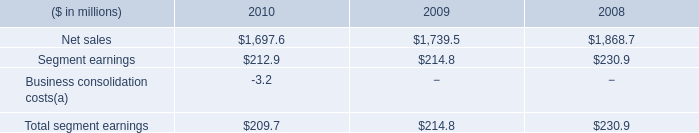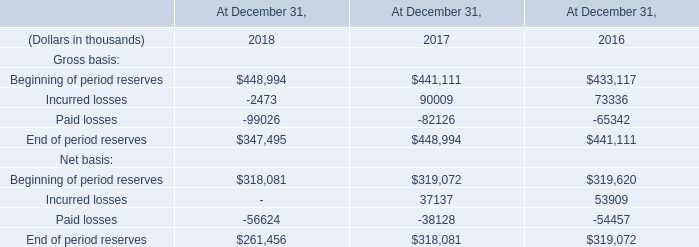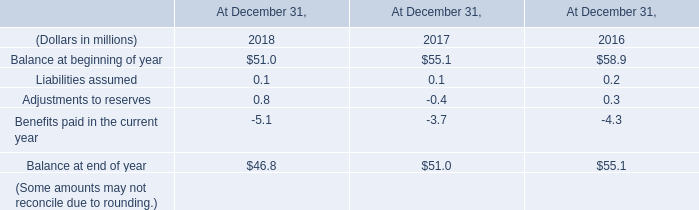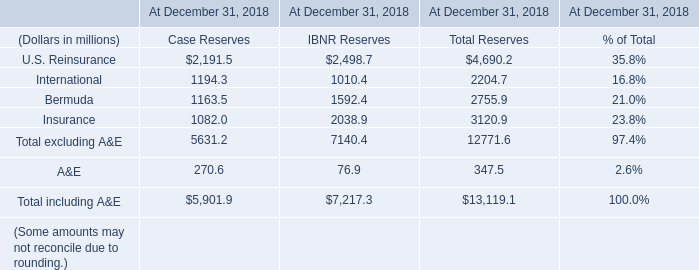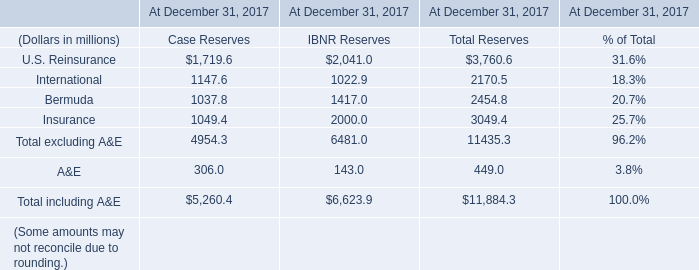what was the percentage change in net sales metal beverage packaging , europe between 2008 to 2009? 
Computations: ((1739.5 - 1868.7) / 1868.7)
Answer: -0.06914. 